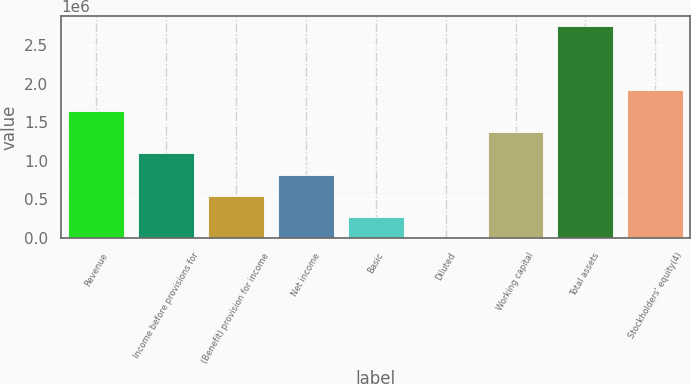<chart> <loc_0><loc_0><loc_500><loc_500><bar_chart><fcel>Revenue<fcel>Income before provisions for<fcel>(Benefit) provision for income<fcel>Net income<fcel>Basic<fcel>Diluted<fcel>Working capital<fcel>Total assets<fcel>Stockholders' equity(4)<nl><fcel>1.64549e+06<fcel>1.09699e+06<fcel>548497<fcel>822744<fcel>274249<fcel>1.29<fcel>1.37124e+06<fcel>2.74248e+06<fcel>1.91973e+06<nl></chart> 